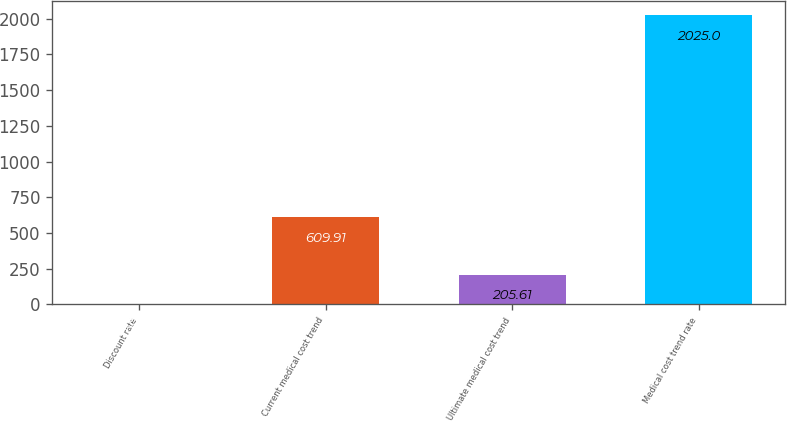Convert chart. <chart><loc_0><loc_0><loc_500><loc_500><bar_chart><fcel>Discount rate<fcel>Current medical cost trend<fcel>Ultimate medical cost trend<fcel>Medical cost trend rate<nl><fcel>3.46<fcel>609.91<fcel>205.61<fcel>2025<nl></chart> 